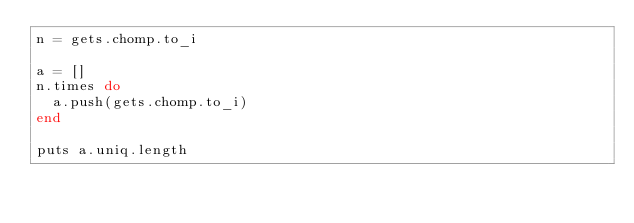Convert code to text. <code><loc_0><loc_0><loc_500><loc_500><_Ruby_>n = gets.chomp.to_i

a = []
n.times do
  a.push(gets.chomp.to_i)
end

puts a.uniq.length</code> 